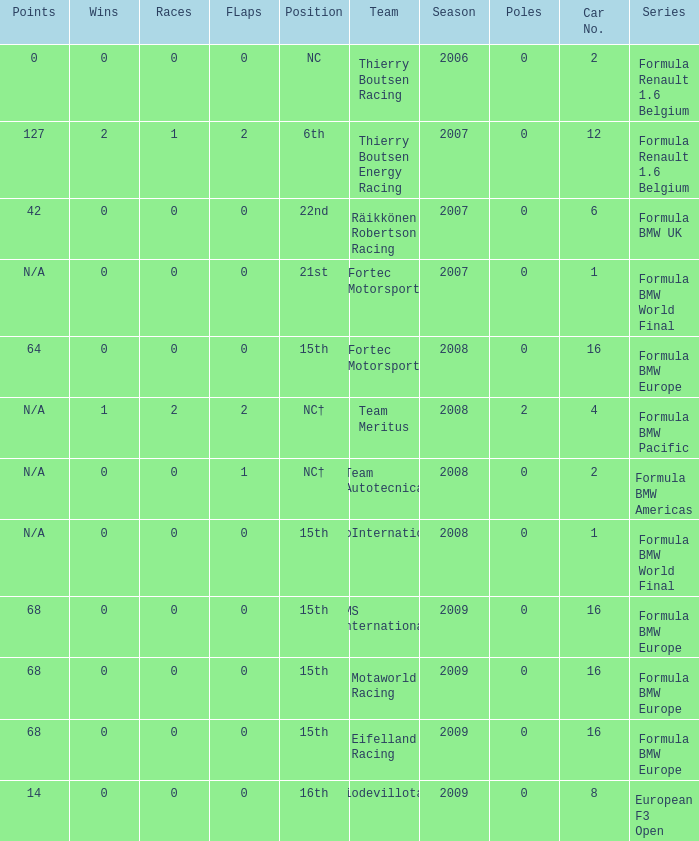Name the position for eifelland racing 15th. 